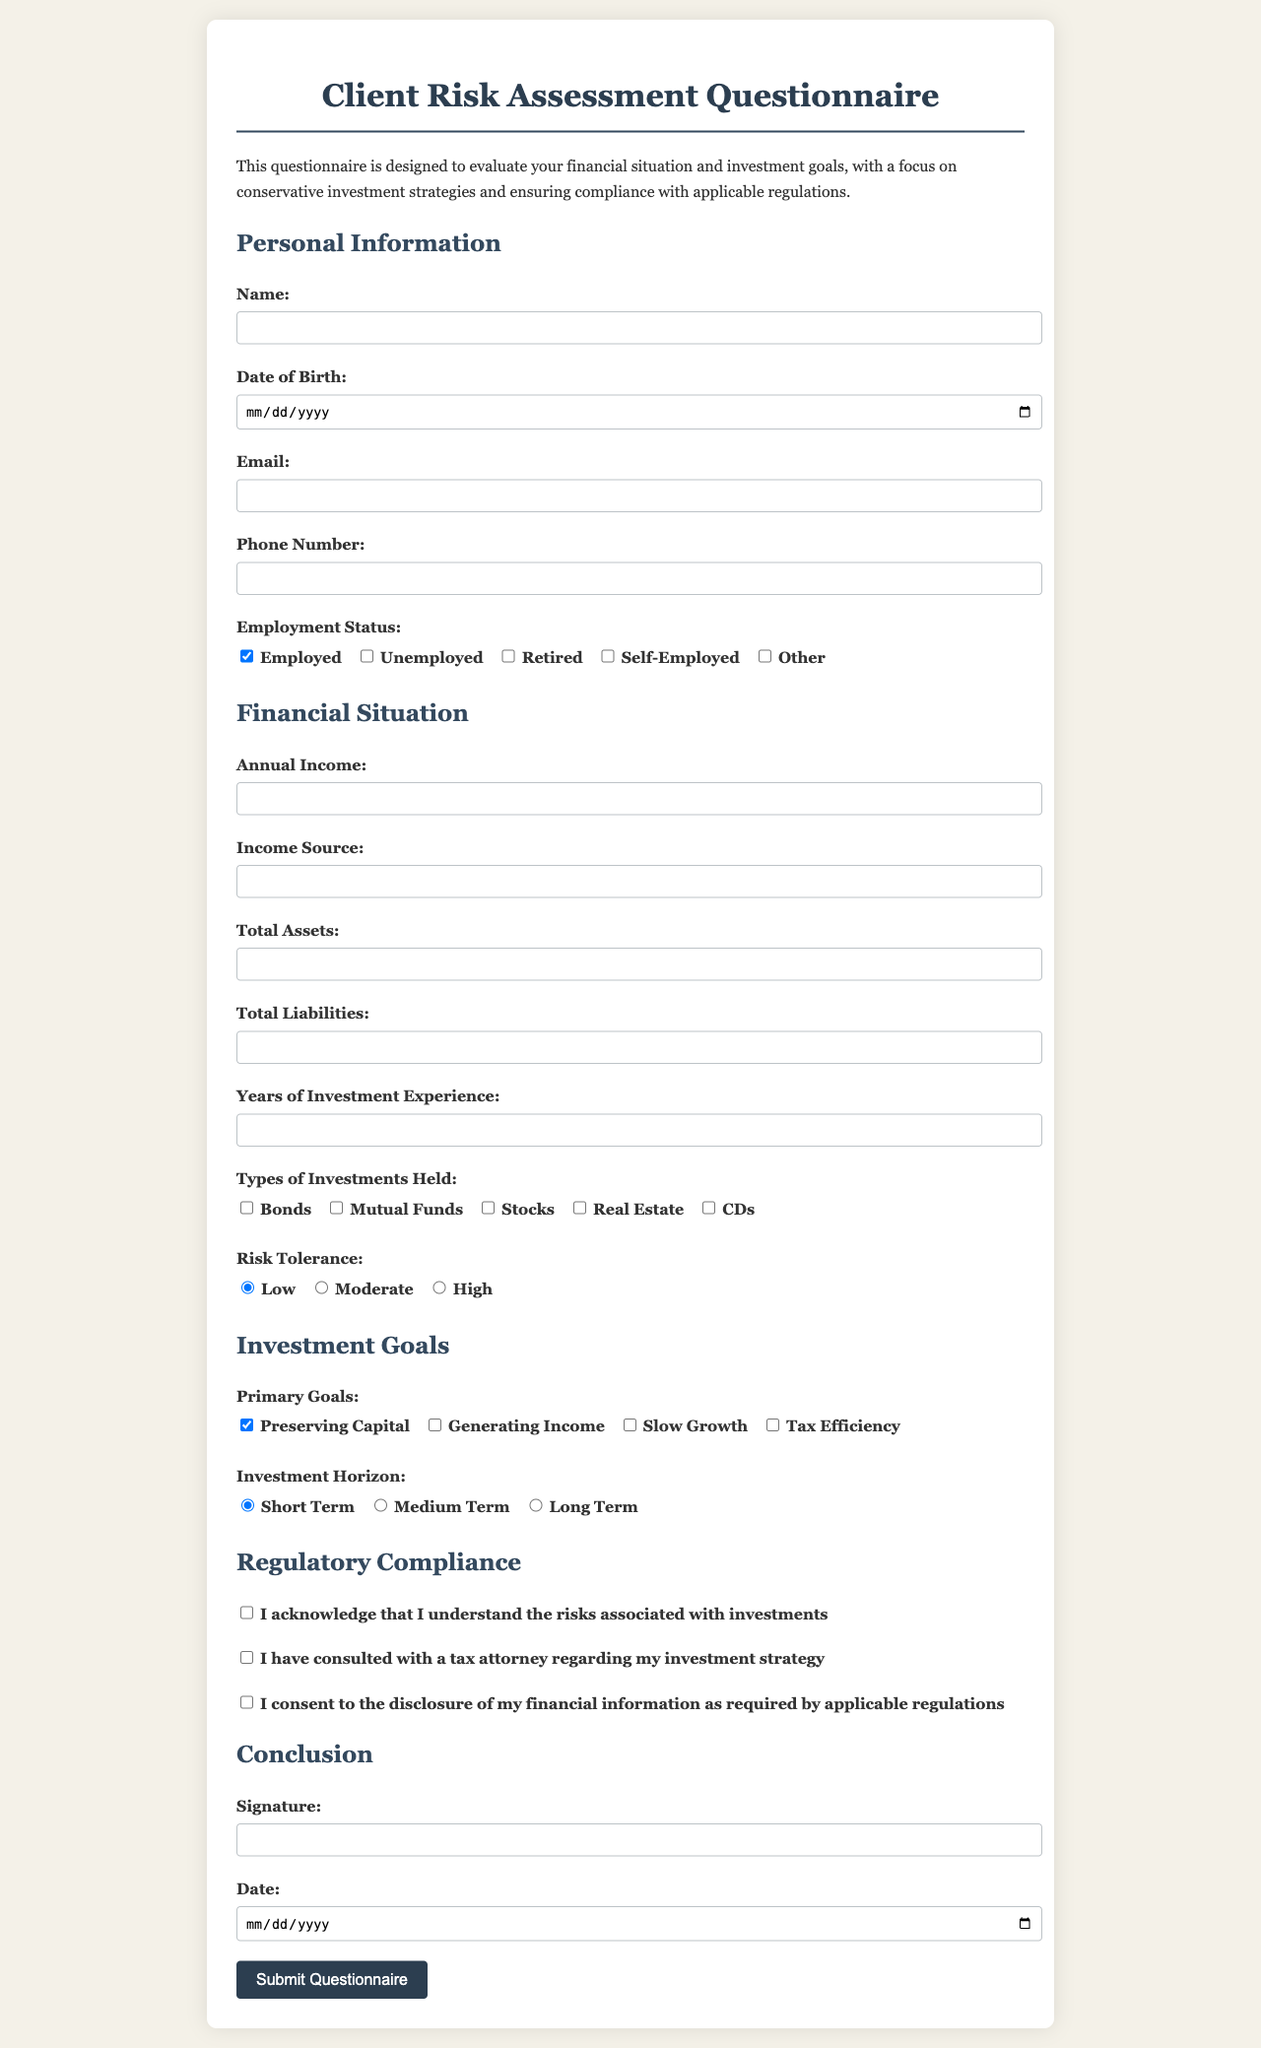What is the title of the document? The title is at the top of the document and indicates its purpose.
Answer: Client Risk Assessment Questionnaire What is the required annual income format? The format is specified in the input field for annual income, indicating it should be a numerical value.
Answer: Number What is the primary investment goal listed in the questionnaire? The primary investment goal is the first option mentioned under investment goals.
Answer: Preserving Capital How many types of investments can be selected? The options are listed under types of investments held, and the total number of options provided gives the answer.
Answer: Five What is the risk tolerance option selected by default? The default selected risk tolerance option is indicated in the radio buttons section.
Answer: Low What must the client acknowledge regarding investments? This acknowledgment is specified in the regulatory compliance section of the form.
Answer: Understanding risks What is required before submitting the questionnaire? This requirement is stated in the conclusion section where signatures and dates are needed.
Answer: Signature and Date Which checkbox must be checked for regulatory compliance? This checkbox is specifically related to compliance and is outlined in the regulatory section.
Answer: Disclosure consent What is the format of the date required for submission? The format is indicated by the input type given for the date field in the form.
Answer: Date 